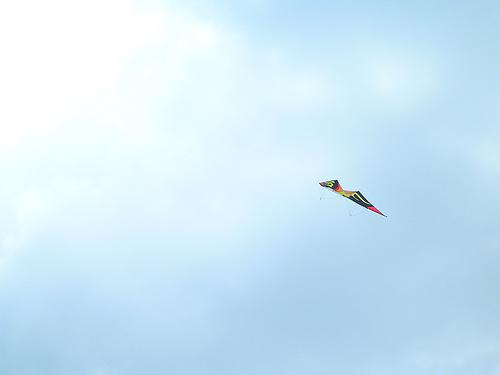Question: what is in the sky?
Choices:
A. A bird.
B. Superman.
C. A kite.
D. A plane.
Answer with the letter. Answer: C Question: where is this picture taken?
Choices:
A. In the water.
B. The sky.
C. On the ground.
D. In a house.
Answer with the letter. Answer: B Question: what color is the kite?
Choices:
A. Blue and red.
B. Yellow.
C. White and purple.
D. Orange and black.
Answer with the letter. Answer: D Question: how is the weather?
Choices:
A. Clear.
B. Sunny.
C. Cloudy.
D. Windy.
Answer with the letter. Answer: A Question: how is the kite shaped?
Choices:
A. Like a bird.
B. Like a plane.
C. Like a dragon.
D. Like a cow.
Answer with the letter. Answer: A Question: what color is the sky?
Choices:
A. White.
B. Black.
C. Blue.
D. Gray.
Answer with the letter. Answer: C 